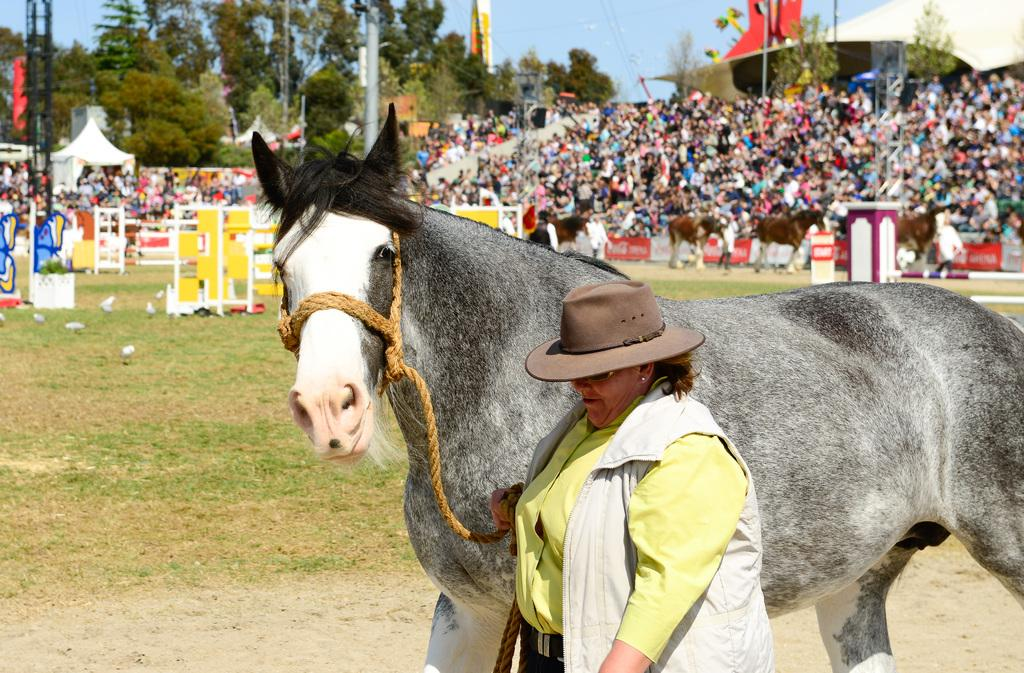What animal is present in the image? There is a horse in the image. Can you describe the woman in the image? The woman is wearing a hat in the image. What can be seen in the background of the image? In the background of the image, there are poles, rods, hoardings, people, horses, trees, a tent, and the sky. What type of print can be seen on the woman's dress in the image? There is no information about the woman's dress in the provided facts, so we cannot determine if there is any print on it. 